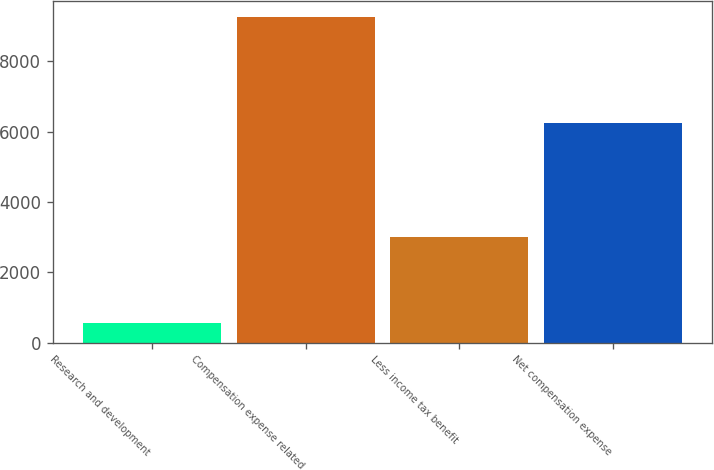Convert chart. <chart><loc_0><loc_0><loc_500><loc_500><bar_chart><fcel>Research and development<fcel>Compensation expense related<fcel>Less income tax benefit<fcel>Net compensation expense<nl><fcel>554<fcel>9246<fcel>3014<fcel>6232<nl></chart> 